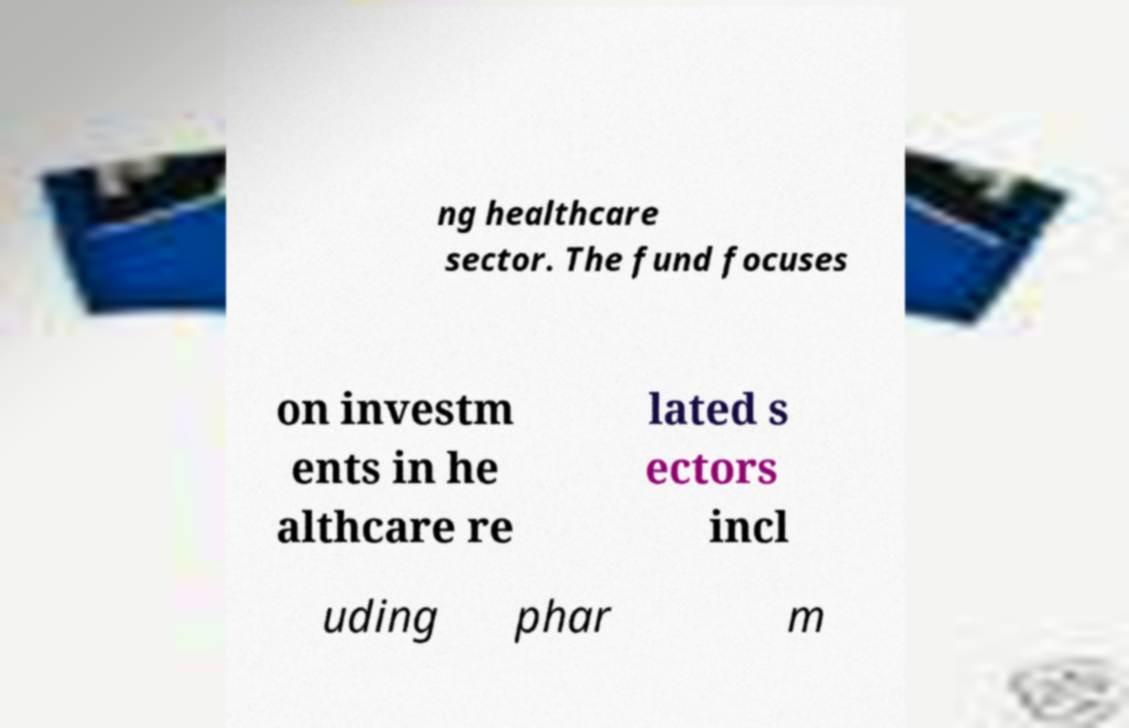Can you read and provide the text displayed in the image?This photo seems to have some interesting text. Can you extract and type it out for me? ng healthcare sector. The fund focuses on investm ents in he althcare re lated s ectors incl uding phar m 